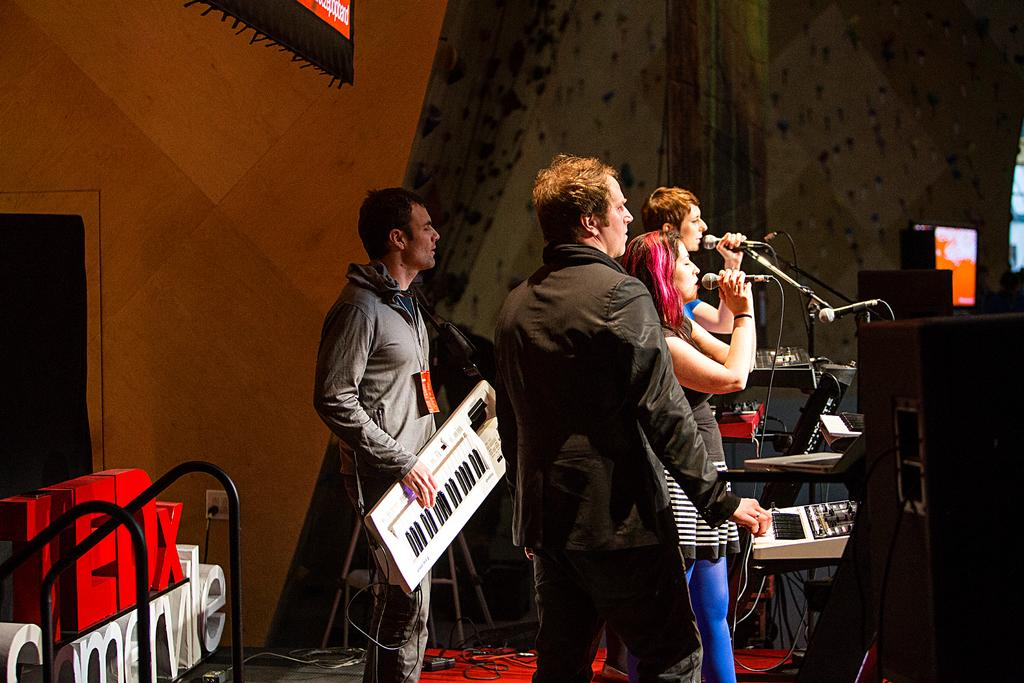What is happening in the image? There is a band of people in the image, and they are playing music. Where are the people playing music located? The band is on a stage. What type of experience does the band have with digestion in the image? There is no information about the band's experience with digestion in the image. 